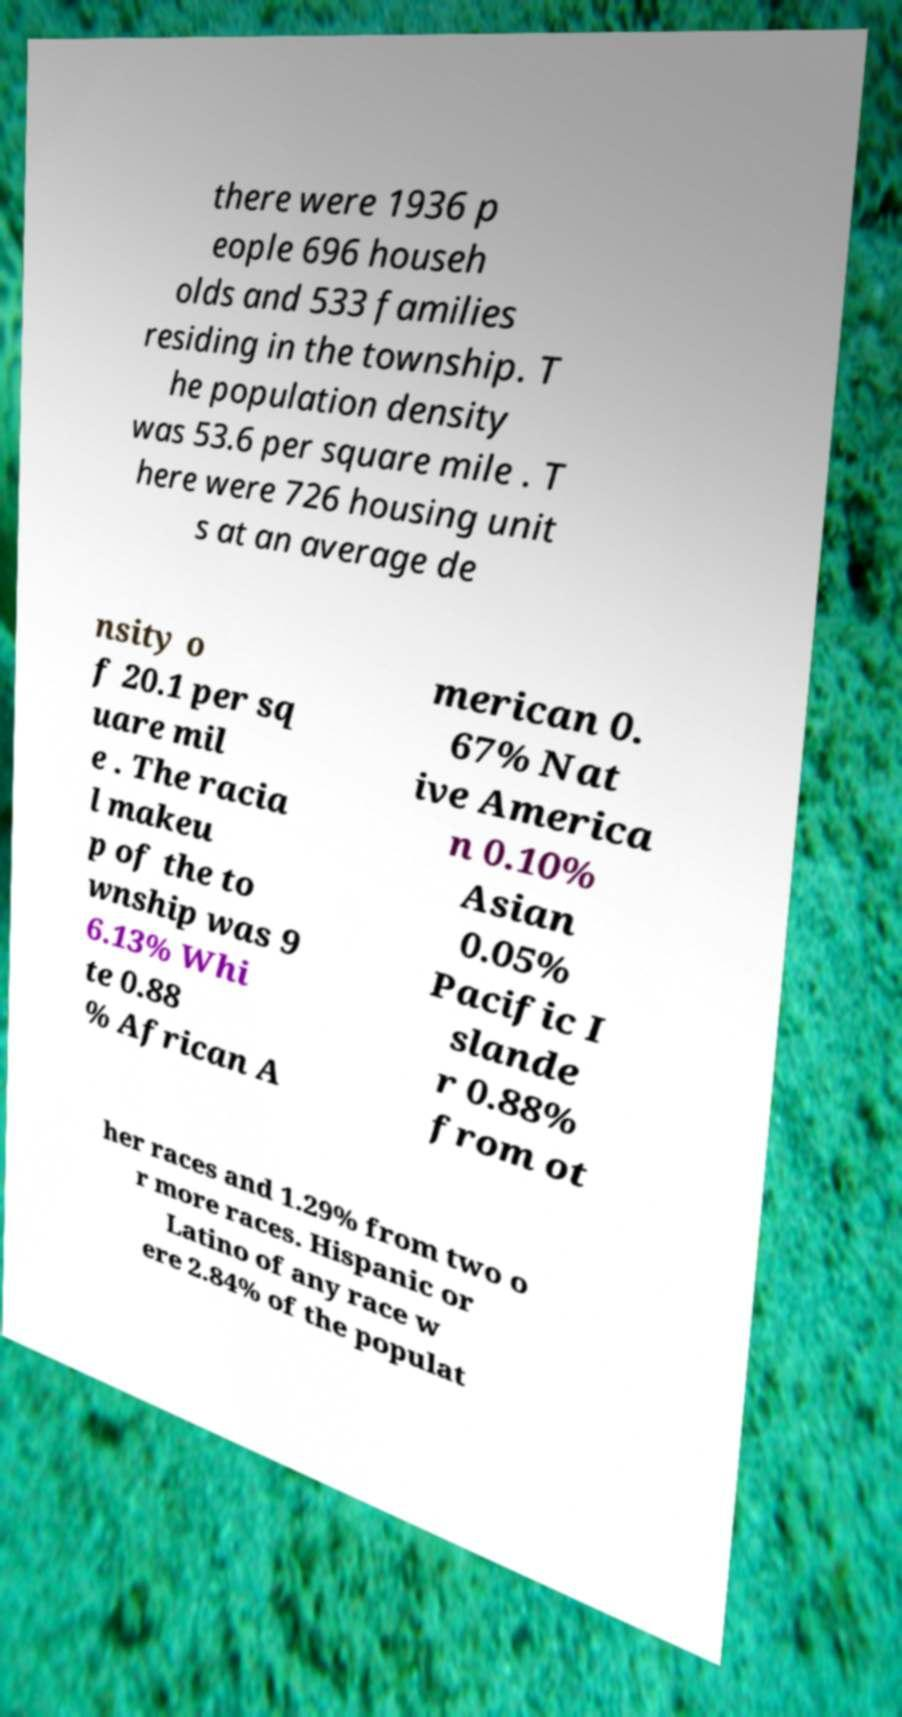Can you read and provide the text displayed in the image?This photo seems to have some interesting text. Can you extract and type it out for me? there were 1936 p eople 696 househ olds and 533 families residing in the township. T he population density was 53.6 per square mile . T here were 726 housing unit s at an average de nsity o f 20.1 per sq uare mil e . The racia l makeu p of the to wnship was 9 6.13% Whi te 0.88 % African A merican 0. 67% Nat ive America n 0.10% Asian 0.05% Pacific I slande r 0.88% from ot her races and 1.29% from two o r more races. Hispanic or Latino of any race w ere 2.84% of the populat 